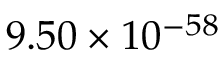<formula> <loc_0><loc_0><loc_500><loc_500>9 . 5 0 \times 1 0 ^ { - 5 8 }</formula> 